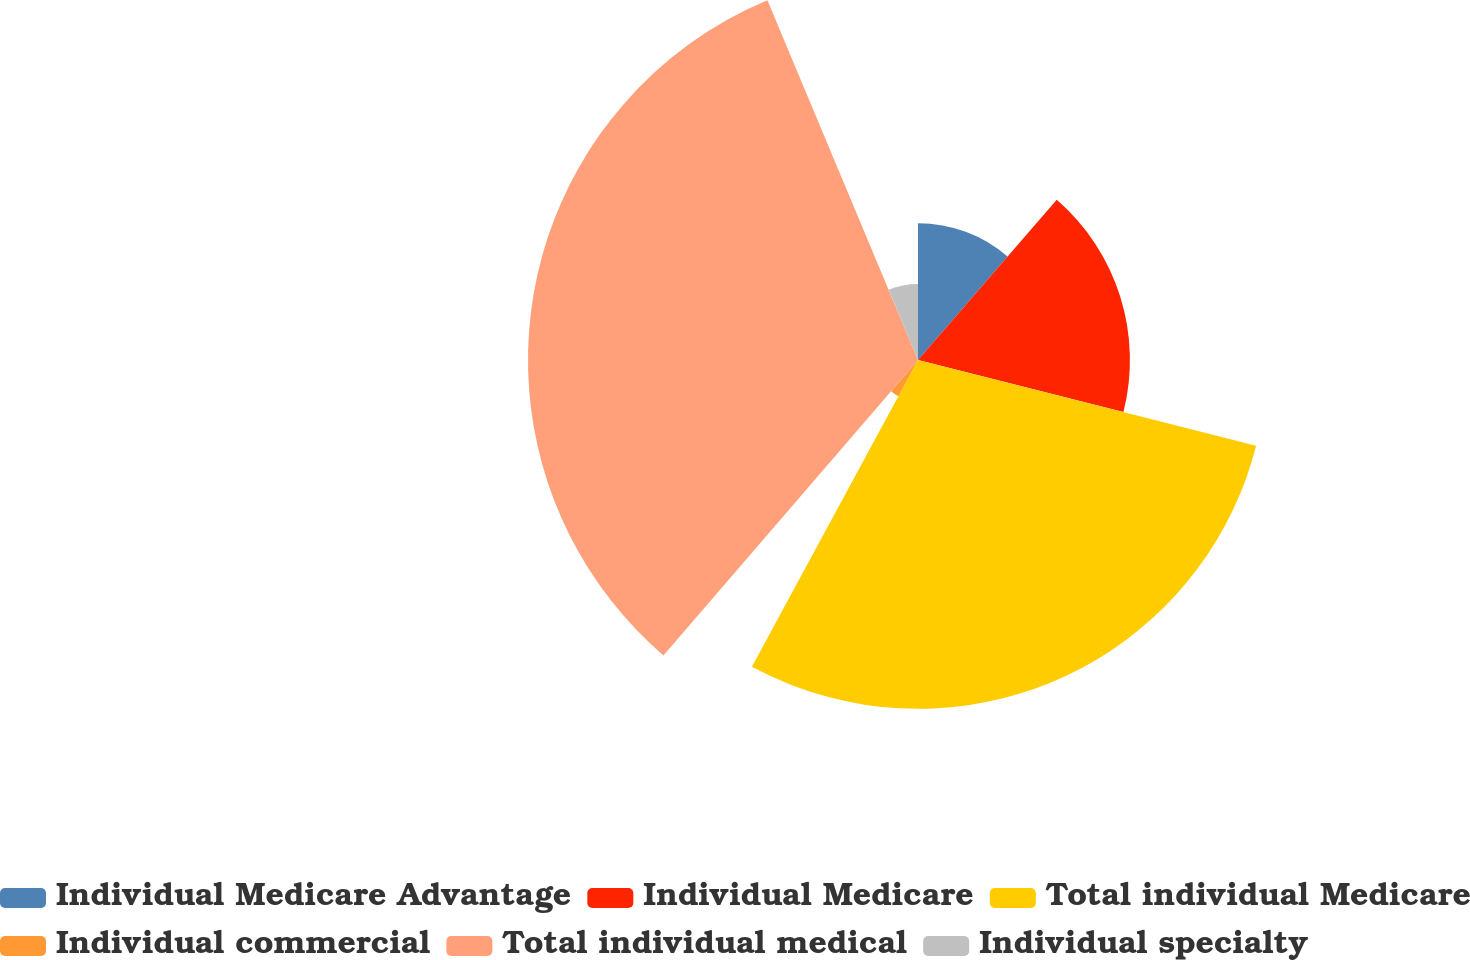<chart> <loc_0><loc_0><loc_500><loc_500><pie_chart><fcel>Individual Medicare Advantage<fcel>Individual Medicare<fcel>Total individual Medicare<fcel>Individual commercial<fcel>Total individual medical<fcel>Individual specialty<nl><fcel>11.36%<fcel>17.59%<fcel>28.95%<fcel>3.42%<fcel>32.37%<fcel>6.31%<nl></chart> 